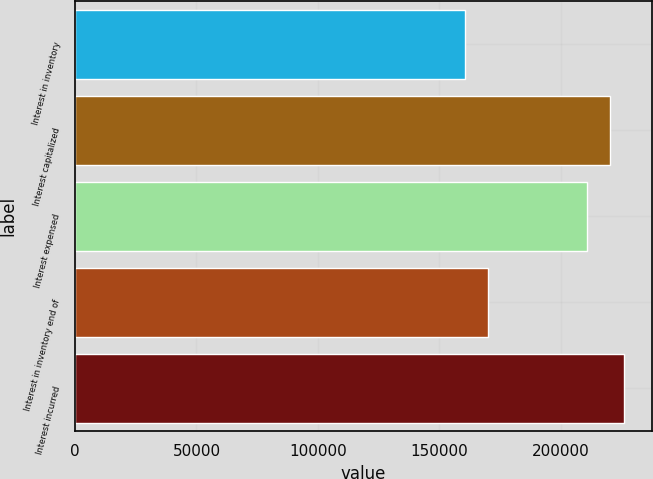Convert chart to OTSL. <chart><loc_0><loc_0><loc_500><loc_500><bar_chart><fcel>Interest in inventory<fcel>Interest capitalized<fcel>Interest expensed<fcel>Interest in inventory end of<fcel>Interest incurred<nl><fcel>160598<fcel>220131<fcel>210709<fcel>170020<fcel>226084<nl></chart> 